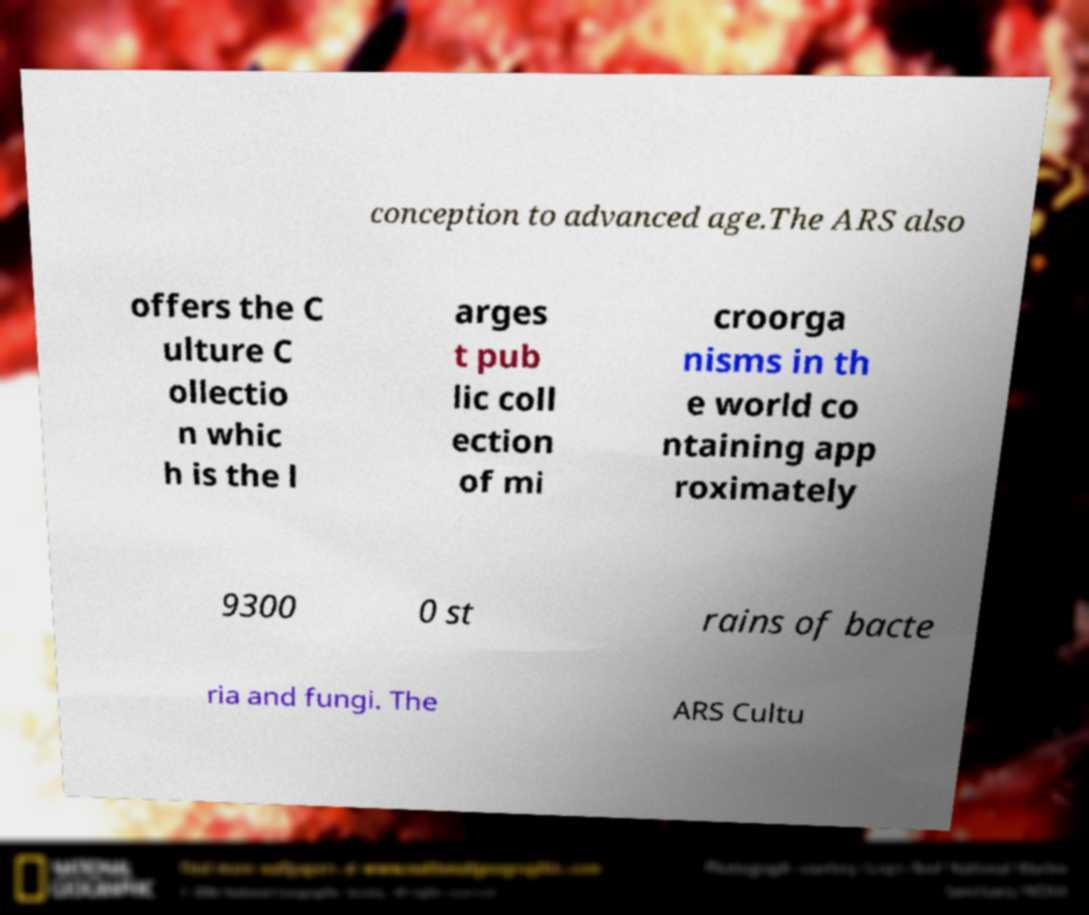Could you extract and type out the text from this image? conception to advanced age.The ARS also offers the C ulture C ollectio n whic h is the l arges t pub lic coll ection of mi croorga nisms in th e world co ntaining app roximately 9300 0 st rains of bacte ria and fungi. The ARS Cultu 